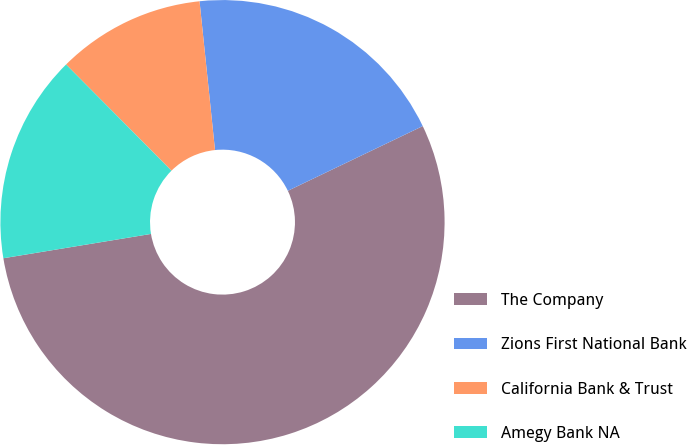Convert chart. <chart><loc_0><loc_0><loc_500><loc_500><pie_chart><fcel>The Company<fcel>Zions First National Bank<fcel>California Bank & Trust<fcel>Amegy Bank NA<nl><fcel>54.52%<fcel>19.53%<fcel>10.79%<fcel>15.16%<nl></chart> 